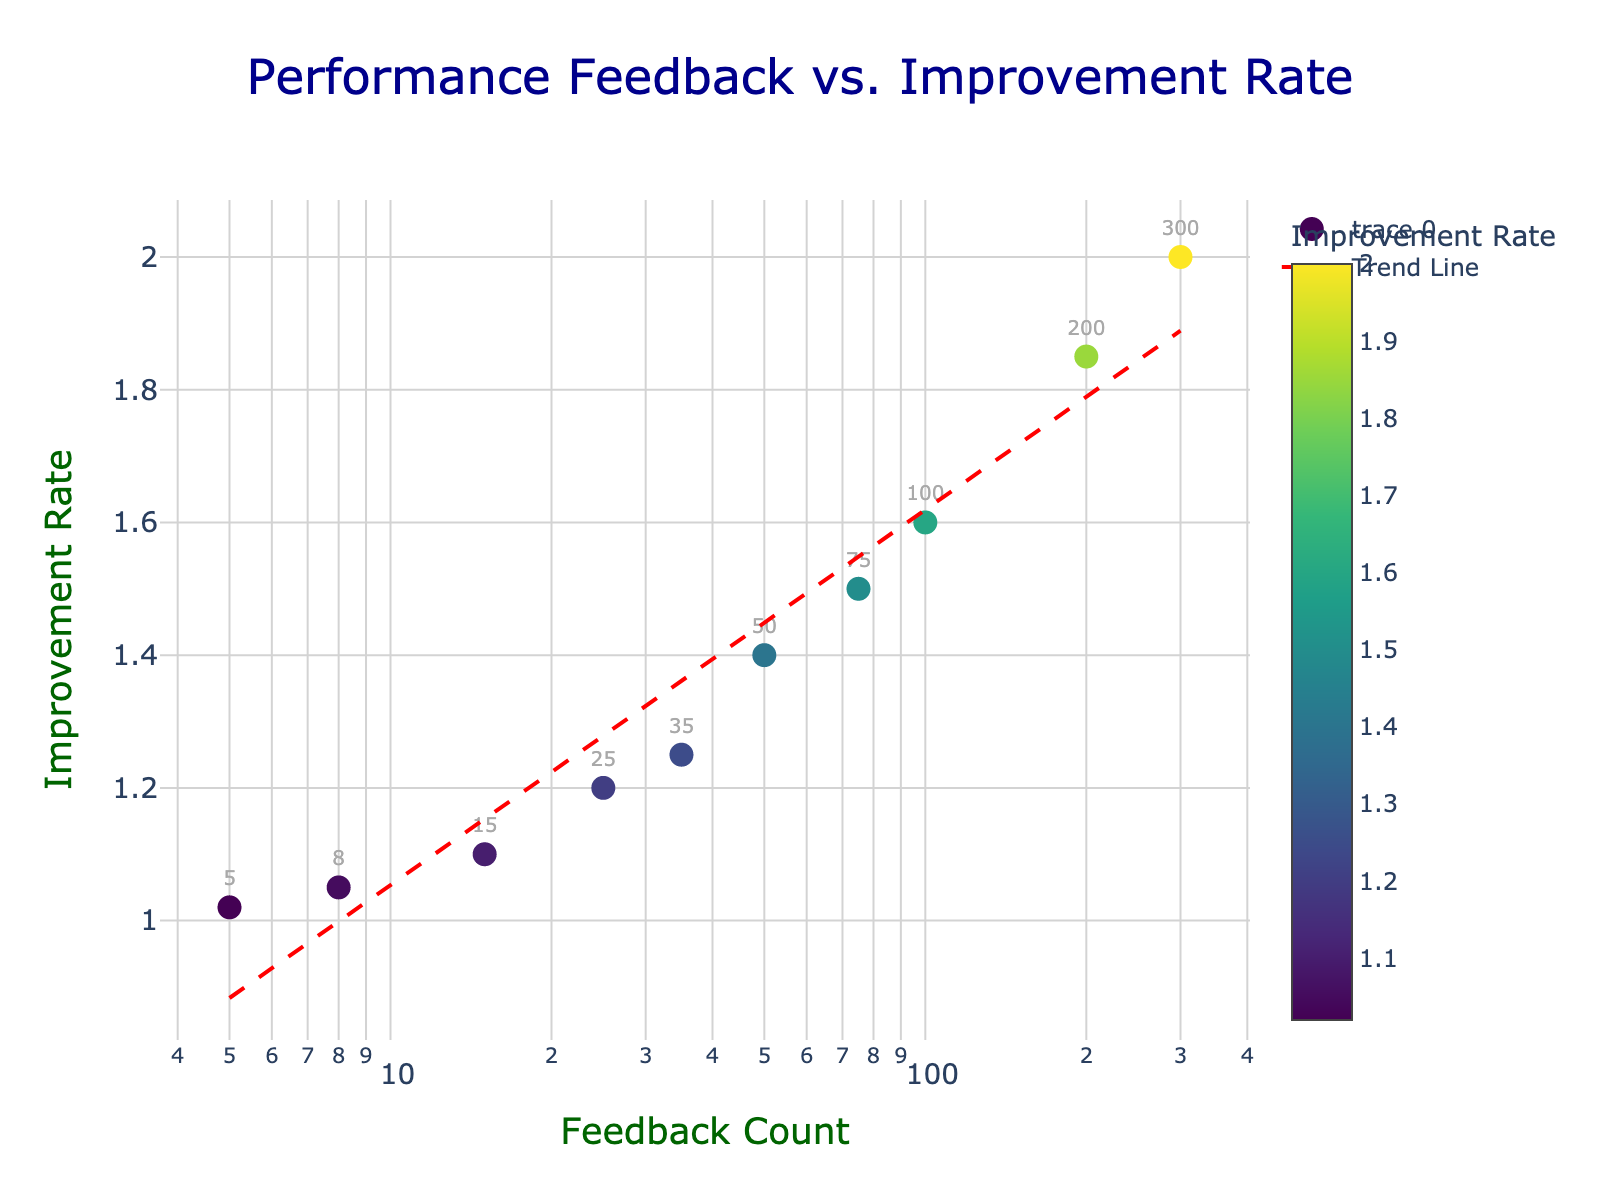What's the title of the plot? The title is displayed at the top center of the plot area.
Answer: Performance Feedback vs. Improvement Rate What is represented on the X-axis? The X-axis title indicates what is plotted, and it is labeled as "Feedback Count".
Answer: Feedback Count How are the colors of the markers determined? The colors of the markers are determined by the Improvement Rate values, displayed on the color scale to the right of the plot.
Answer: By Improvement Rate values How many data points are plotted in the scatter plot? There are labeled markers corresponding to each data point. We can count them to determine the total number.
Answer: 10 What is the Improvement Rate when the Feedback Count is 100? Find the marker with the label '100' and read its corresponding Improvement Rate from the Y-axis.
Answer: 1.60 Which Feedback Count corresponds to the highest Improvement Rate? Identify the talles marker on the Y-axis and read its Feedback Count from the marker's label.
Answer: 300 What's the difference in Improvement Rate between Feedback Count 75 and Feedback Count 15? Locate the markers at Feedback Counts 75 and 15, note their Improvement Rates, and subtract to find the difference (1.50 - 1.10).
Answer: 0.40 What trend or relationship is indicated by the trend line in the plot? The trend line shows the general direction of data points, indicating that as Feedback Count increases, the Improvement Rate also tends to increase.
Answer: Positive correlation Does the plot use a linear or logarithmic scale for the X-axis? The X-axis shows a log scale because of the increasing intervals and the "log" label.
Answer: Logarithmic 